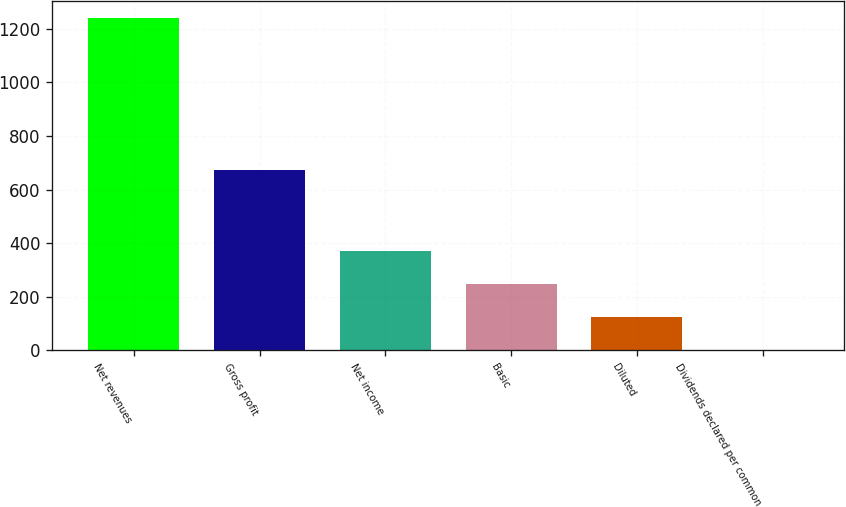Convert chart. <chart><loc_0><loc_0><loc_500><loc_500><bar_chart><fcel>Net revenues<fcel>Gross profit<fcel>Net income<fcel>Basic<fcel>Diluted<fcel>Dividends declared per common<nl><fcel>1240.9<fcel>674.4<fcel>372.31<fcel>248.23<fcel>124.14<fcel>0.05<nl></chart> 